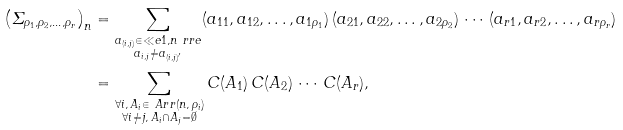<formula> <loc_0><loc_0><loc_500><loc_500>\left ( \varSigma _ { \rho _ { 1 } , \rho _ { 2 } , \dots , \rho _ { r } } \right ) _ { n } & = \sum _ { \substack { a _ { ( i , j ) } \in \ll e 1 , n \ r r e \\ a _ { i , j } \neq a _ { ( i , j ) ^ { \prime } } } } ( a _ { 1 1 } , a _ { 1 2 } , \dots , a _ { 1 \rho _ { 1 } } ) \, ( a _ { 2 1 } , a _ { 2 2 } , \dots , a _ { 2 \rho _ { 2 } } ) \, \cdots \, ( a _ { r 1 } , a _ { r 2 } , \dots , a _ { r \rho _ { r } } ) \\ & = \sum _ { \substack { \forall i , \, A _ { i } \in \ A r r ( n , \, \rho _ { i } ) \\ \forall i \neq j , \, A _ { i } \cap A _ { j } = \emptyset } } C ( A _ { 1 } ) \, C ( A _ { 2 } ) \, \cdots \, C ( A _ { r } ) ,</formula> 